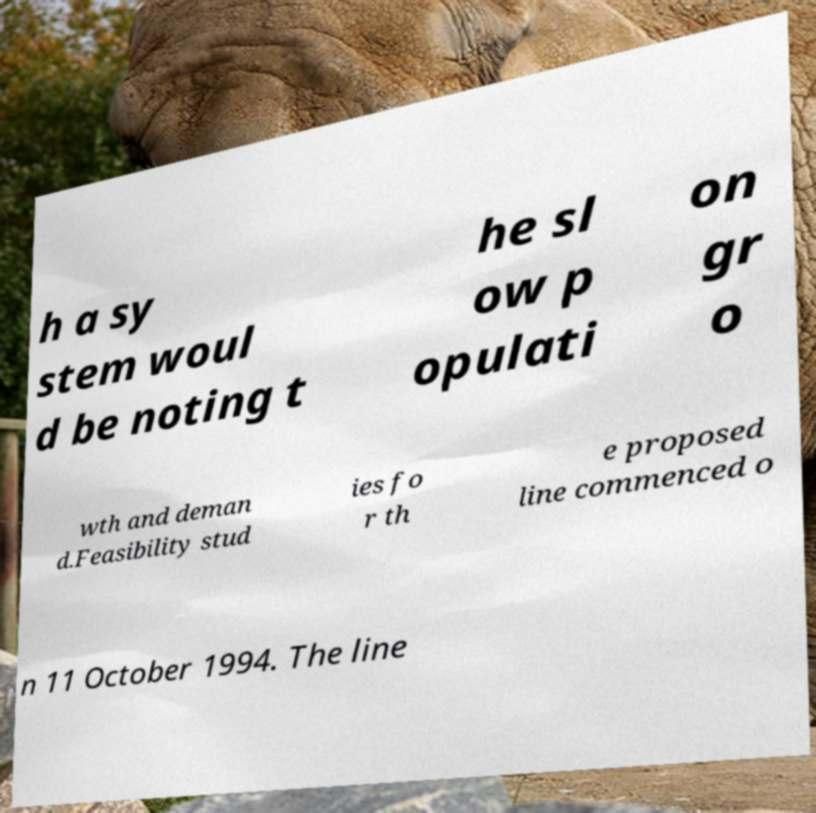There's text embedded in this image that I need extracted. Can you transcribe it verbatim? h a sy stem woul d be noting t he sl ow p opulati on gr o wth and deman d.Feasibility stud ies fo r th e proposed line commenced o n 11 October 1994. The line 